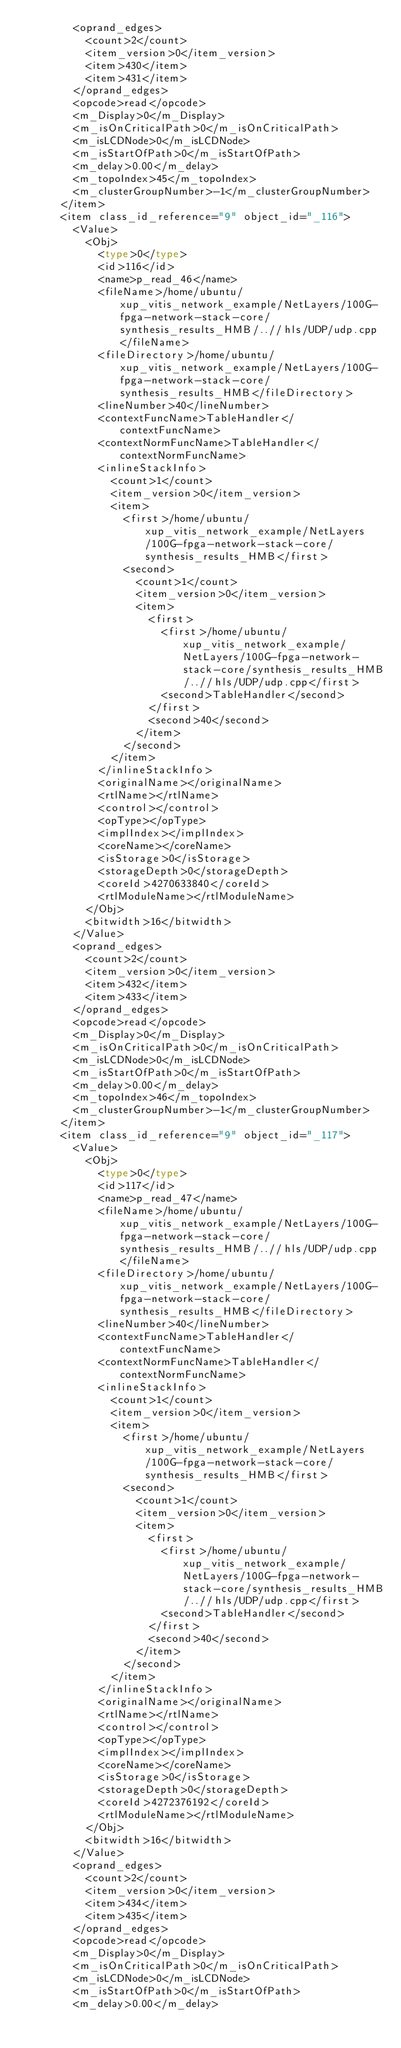<code> <loc_0><loc_0><loc_500><loc_500><_Ada_>				<oprand_edges>
					<count>2</count>
					<item_version>0</item_version>
					<item>430</item>
					<item>431</item>
				</oprand_edges>
				<opcode>read</opcode>
				<m_Display>0</m_Display>
				<m_isOnCriticalPath>0</m_isOnCriticalPath>
				<m_isLCDNode>0</m_isLCDNode>
				<m_isStartOfPath>0</m_isStartOfPath>
				<m_delay>0.00</m_delay>
				<m_topoIndex>45</m_topoIndex>
				<m_clusterGroupNumber>-1</m_clusterGroupNumber>
			</item>
			<item class_id_reference="9" object_id="_116">
				<Value>
					<Obj>
						<type>0</type>
						<id>116</id>
						<name>p_read_46</name>
						<fileName>/home/ubuntu/xup_vitis_network_example/NetLayers/100G-fpga-network-stack-core/synthesis_results_HMB/..//hls/UDP/udp.cpp</fileName>
						<fileDirectory>/home/ubuntu/xup_vitis_network_example/NetLayers/100G-fpga-network-stack-core/synthesis_results_HMB</fileDirectory>
						<lineNumber>40</lineNumber>
						<contextFuncName>TableHandler</contextFuncName>
						<contextNormFuncName>TableHandler</contextNormFuncName>
						<inlineStackInfo>
							<count>1</count>
							<item_version>0</item_version>
							<item>
								<first>/home/ubuntu/xup_vitis_network_example/NetLayers/100G-fpga-network-stack-core/synthesis_results_HMB</first>
								<second>
									<count>1</count>
									<item_version>0</item_version>
									<item>
										<first>
											<first>/home/ubuntu/xup_vitis_network_example/NetLayers/100G-fpga-network-stack-core/synthesis_results_HMB/..//hls/UDP/udp.cpp</first>
											<second>TableHandler</second>
										</first>
										<second>40</second>
									</item>
								</second>
							</item>
						</inlineStackInfo>
						<originalName></originalName>
						<rtlName></rtlName>
						<control></control>
						<opType></opType>
						<implIndex></implIndex>
						<coreName></coreName>
						<isStorage>0</isStorage>
						<storageDepth>0</storageDepth>
						<coreId>4270633840</coreId>
						<rtlModuleName></rtlModuleName>
					</Obj>
					<bitwidth>16</bitwidth>
				</Value>
				<oprand_edges>
					<count>2</count>
					<item_version>0</item_version>
					<item>432</item>
					<item>433</item>
				</oprand_edges>
				<opcode>read</opcode>
				<m_Display>0</m_Display>
				<m_isOnCriticalPath>0</m_isOnCriticalPath>
				<m_isLCDNode>0</m_isLCDNode>
				<m_isStartOfPath>0</m_isStartOfPath>
				<m_delay>0.00</m_delay>
				<m_topoIndex>46</m_topoIndex>
				<m_clusterGroupNumber>-1</m_clusterGroupNumber>
			</item>
			<item class_id_reference="9" object_id="_117">
				<Value>
					<Obj>
						<type>0</type>
						<id>117</id>
						<name>p_read_47</name>
						<fileName>/home/ubuntu/xup_vitis_network_example/NetLayers/100G-fpga-network-stack-core/synthesis_results_HMB/..//hls/UDP/udp.cpp</fileName>
						<fileDirectory>/home/ubuntu/xup_vitis_network_example/NetLayers/100G-fpga-network-stack-core/synthesis_results_HMB</fileDirectory>
						<lineNumber>40</lineNumber>
						<contextFuncName>TableHandler</contextFuncName>
						<contextNormFuncName>TableHandler</contextNormFuncName>
						<inlineStackInfo>
							<count>1</count>
							<item_version>0</item_version>
							<item>
								<first>/home/ubuntu/xup_vitis_network_example/NetLayers/100G-fpga-network-stack-core/synthesis_results_HMB</first>
								<second>
									<count>1</count>
									<item_version>0</item_version>
									<item>
										<first>
											<first>/home/ubuntu/xup_vitis_network_example/NetLayers/100G-fpga-network-stack-core/synthesis_results_HMB/..//hls/UDP/udp.cpp</first>
											<second>TableHandler</second>
										</first>
										<second>40</second>
									</item>
								</second>
							</item>
						</inlineStackInfo>
						<originalName></originalName>
						<rtlName></rtlName>
						<control></control>
						<opType></opType>
						<implIndex></implIndex>
						<coreName></coreName>
						<isStorage>0</isStorage>
						<storageDepth>0</storageDepth>
						<coreId>4272376192</coreId>
						<rtlModuleName></rtlModuleName>
					</Obj>
					<bitwidth>16</bitwidth>
				</Value>
				<oprand_edges>
					<count>2</count>
					<item_version>0</item_version>
					<item>434</item>
					<item>435</item>
				</oprand_edges>
				<opcode>read</opcode>
				<m_Display>0</m_Display>
				<m_isOnCriticalPath>0</m_isOnCriticalPath>
				<m_isLCDNode>0</m_isLCDNode>
				<m_isStartOfPath>0</m_isStartOfPath>
				<m_delay>0.00</m_delay></code> 